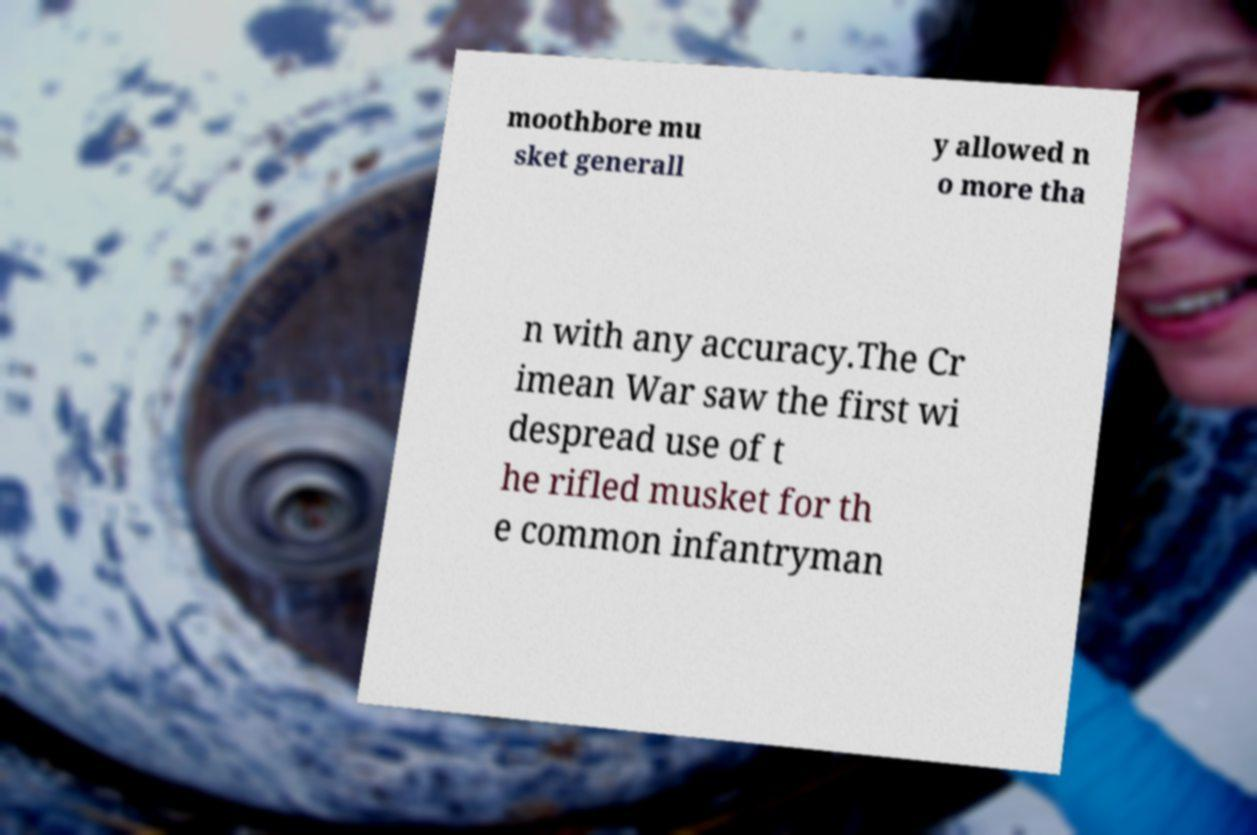There's text embedded in this image that I need extracted. Can you transcribe it verbatim? moothbore mu sket generall y allowed n o more tha n with any accuracy.The Cr imean War saw the first wi despread use of t he rifled musket for th e common infantryman 